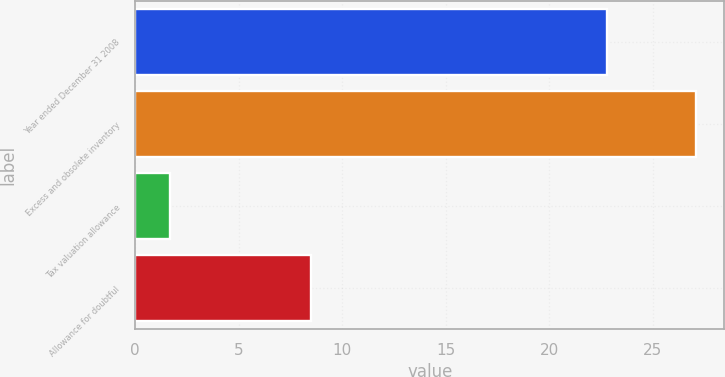Convert chart to OTSL. <chart><loc_0><loc_0><loc_500><loc_500><bar_chart><fcel>Year ended December 31 2008<fcel>Excess and obsolete inventory<fcel>Tax valuation allowance<fcel>Allowance for doubtful<nl><fcel>22.8<fcel>27.1<fcel>1.7<fcel>8.5<nl></chart> 